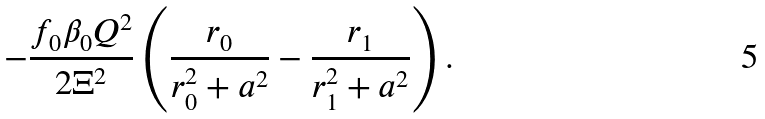Convert formula to latex. <formula><loc_0><loc_0><loc_500><loc_500>- \frac { f _ { 0 } \beta _ { 0 } Q ^ { 2 } } { 2 \Xi ^ { 2 } } \left ( \frac { r _ { 0 } } { r ^ { 2 } _ { 0 } + a ^ { 2 } } - \frac { r _ { 1 } } { r ^ { 2 } _ { 1 } + a ^ { 2 } } \right ) .</formula> 